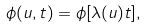Convert formula to latex. <formula><loc_0><loc_0><loc_500><loc_500>\phi ( u , t ) = \phi [ \lambda ( u ) t ] ,</formula> 